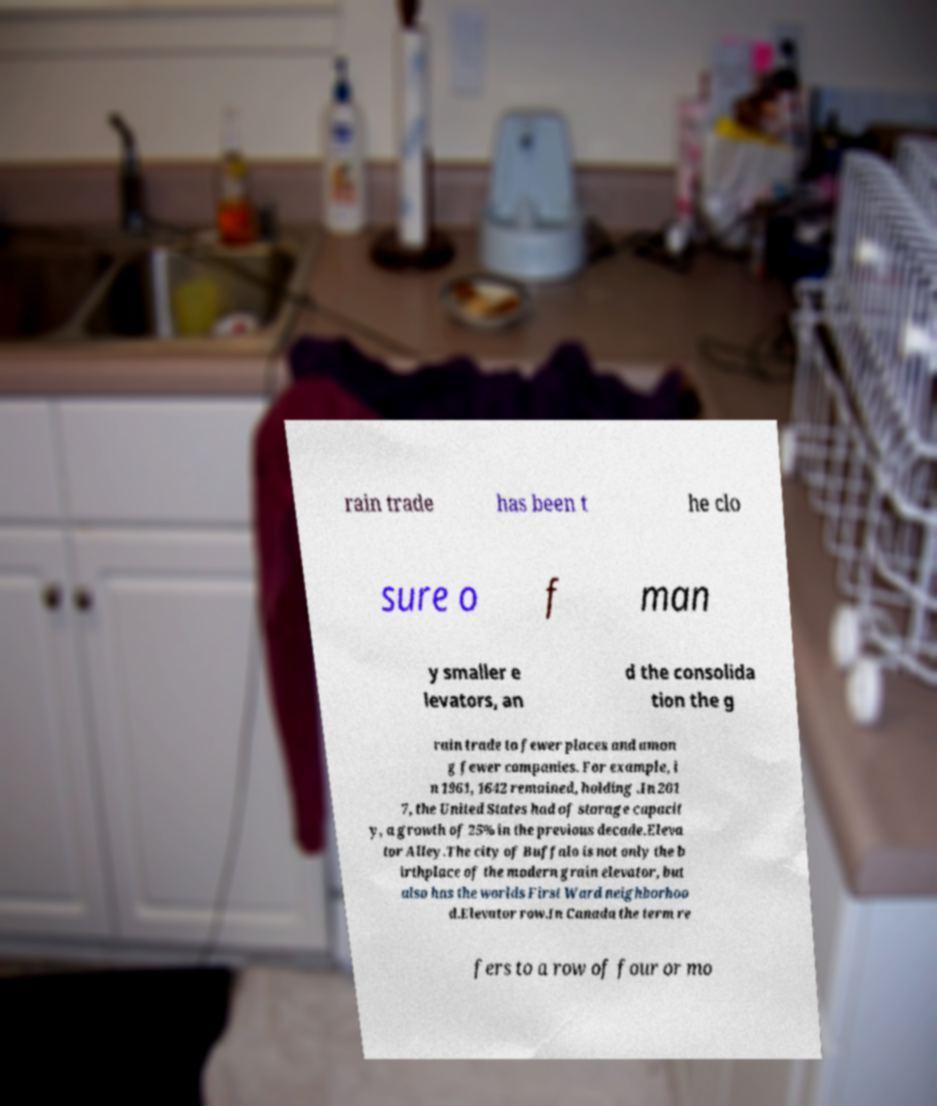What messages or text are displayed in this image? I need them in a readable, typed format. rain trade has been t he clo sure o f man y smaller e levators, an d the consolida tion the g rain trade to fewer places and amon g fewer companies. For example, i n 1961, 1642 remained, holding .In 201 7, the United States had of storage capacit y, a growth of 25% in the previous decade.Eleva tor Alley.The city of Buffalo is not only the b irthplace of the modern grain elevator, but also has the worlds First Ward neighborhoo d.Elevator row.In Canada the term re fers to a row of four or mo 